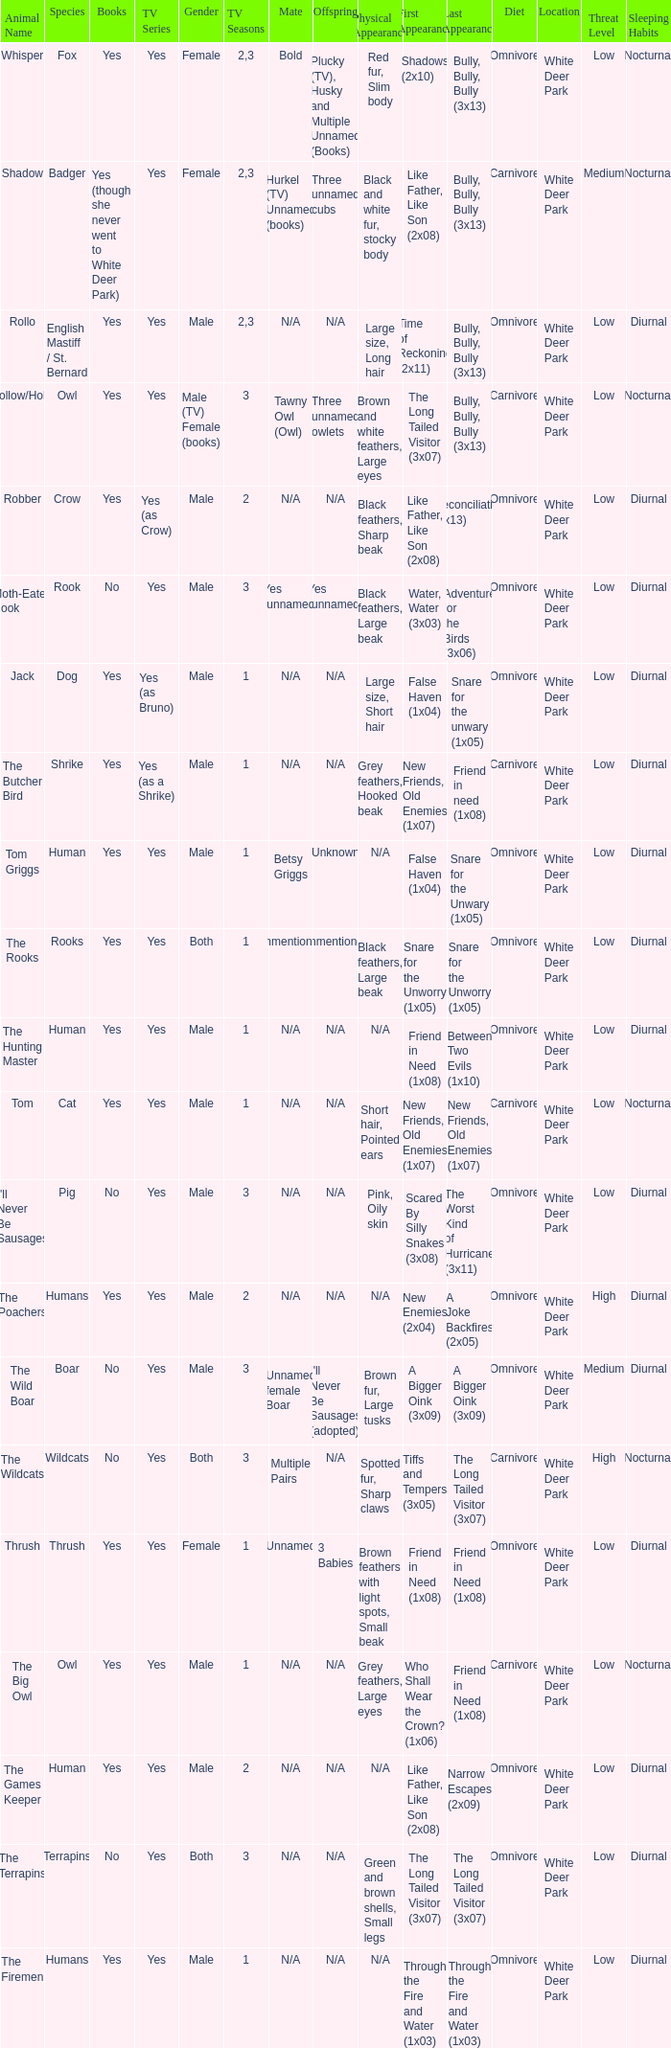What show has a boar? Yes. 